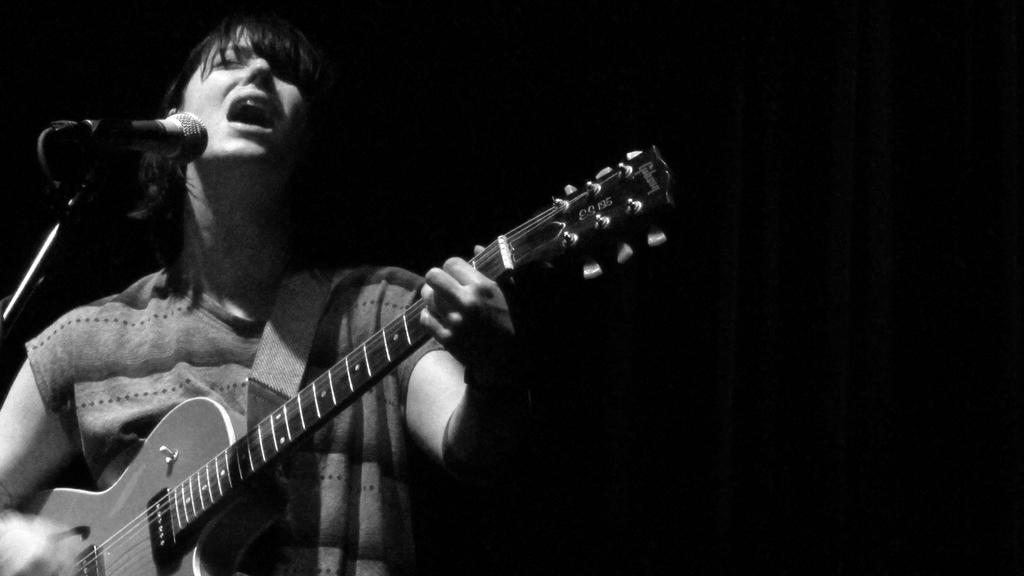What is the person in the image doing? The person is playing a guitar. What is in front of the person that might be used for amplifying their voice? There is a microphone in front of the person. What is the microphone attached to in the image? The microphone is attached to a mic stand in front of the person. What color is the background of the image? The background of the image is black. How many pages can be seen in the image? There are no pages present in the image. What type of beam is holding up the ceiling in the image? There is no beam visible in the image, as the background is black and only the person, guitar, microphone, and mic stand are present. 